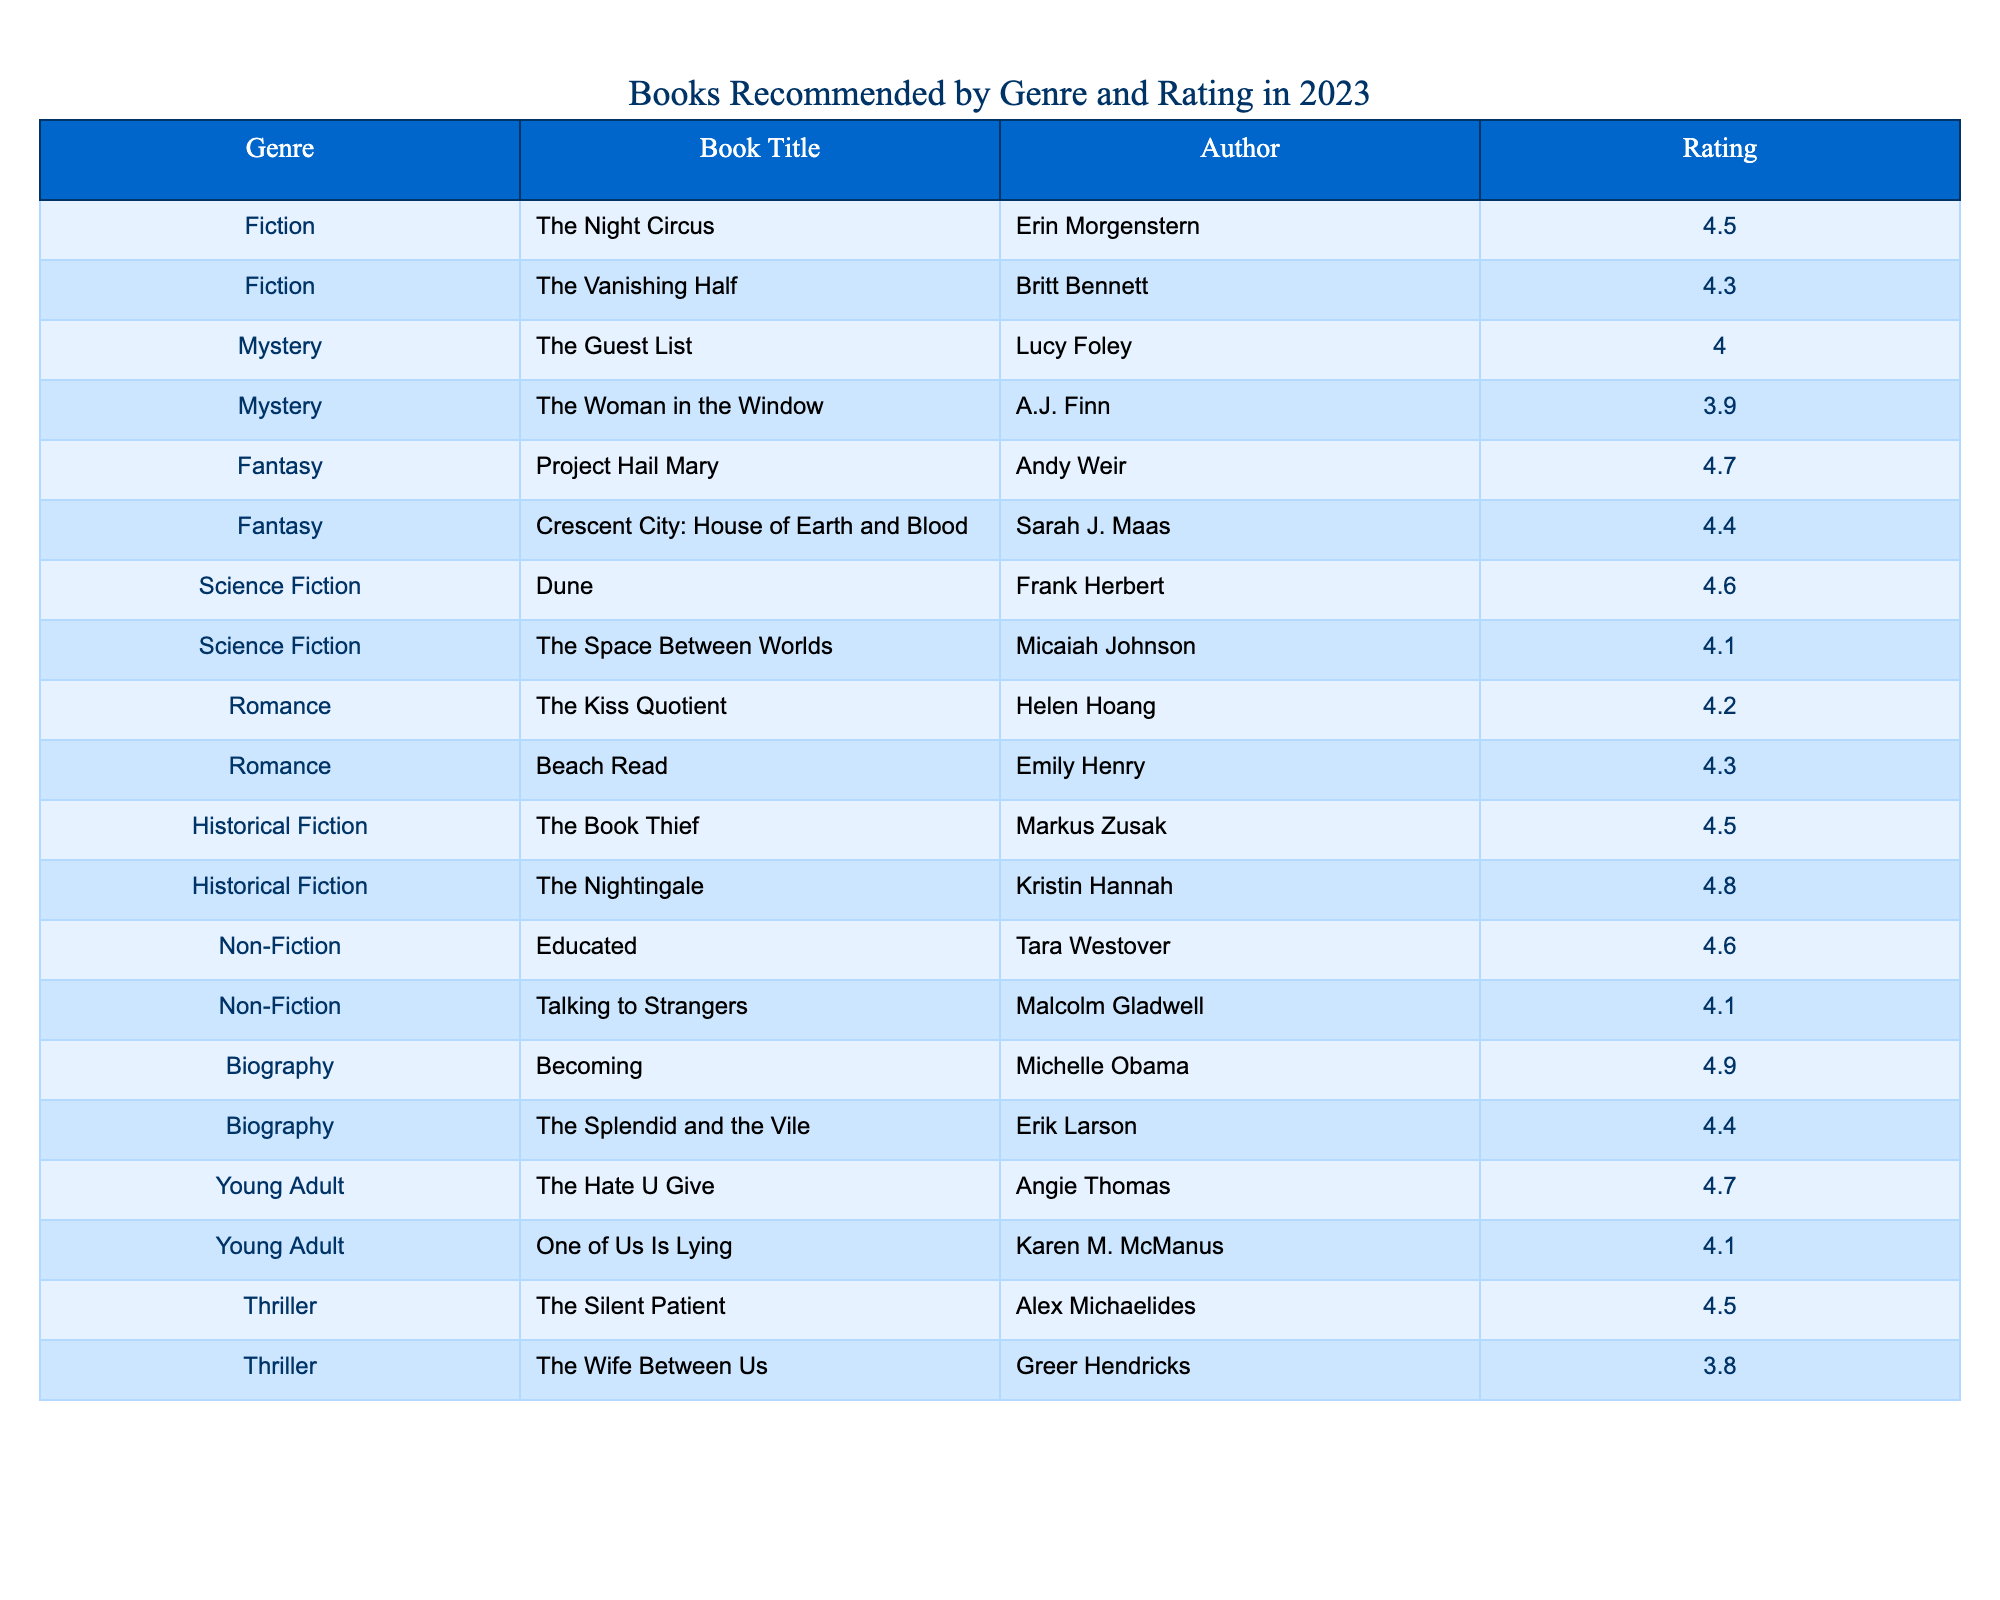What is the highest-rated book in the table? By scanning the ratings in the table, I can find that the highest rating is 4.9, which corresponds to the book "Becoming" by Michelle Obama.
Answer: Becoming Which genre has the most books listed? I can count the number of entries for each genre in the table. Fiction, Mystery, Fantasy, Science Fiction, Romance, Historical Fiction, Non-Fiction, Biography, Young Adult, and Thriller. Fiction, Mystery, and Fantasy have 2 books each, while others have either 1 or 2, confirming that multiple genres have 2 books.
Answer: Fiction, Mystery, and Fantasy What is the average rating of the recommended science fiction books? The ratings for the science fiction books are 4.6 for "Dune" and 4.1 for "The Space Between Worlds." Therefore, to find the average, I sum these ratings: 4.6 + 4.1 = 8.7, and then divide by 2, which results in an average of 4.35.
Answer: 4.35 Is "The Nightingale" rated higher than "The Guest List"? "The Nightingale" has a rating of 4.8 while "The Guest List" is rated at 4.0. Since 4.8 is greater than 4.0, the answer is yes.
Answer: Yes Which author wrote the highest-rated fiction book? I can identify the ratings for the fiction books from the table, where "The Night Circus" by Erin Morgenstern has a rating of 4.5 and "The Vanishing Half" by Britt Bennett has a rating of 4.3. The higher rated book is thus "The Night Circus."
Answer: Erin Morgenstern What genre has the highest average rating? To find the genre with the highest average rating, I first calculate the average ratings for each genre listed in the table. After calculating, I find that Historical Fiction, with books averaging 4.65, has the highest average rating compared to other genres.
Answer: Historical Fiction Are there any romance books with a rating above 4.4? I check the romance book ratings in the table, which are 4.2 and 4.3. Since neither is above 4.4, the answer is no.
Answer: No How many young adult books have a rating of 4.5 or higher? The young adult books listed have ratings of 4.7 and 4.1. Since only one of them (4.7) is above 4.5, the count is 1.
Answer: 1 Which book is the lowest-rated in the thriller genre? I refer to the ratings of the thrillers in the table, which are 4.5 for "The Silent Patient" and 3.8 for "The Wife Between Us." The lowest rating is clearly for "The Wife Between Us."
Answer: The Wife Between Us What is the total number of books listed in the mystery genre? In the table, I see that there are 2 entries for the mystery genre: "The Guest List" and "The Woman in the Window," giving a total of 2 books.
Answer: 2 